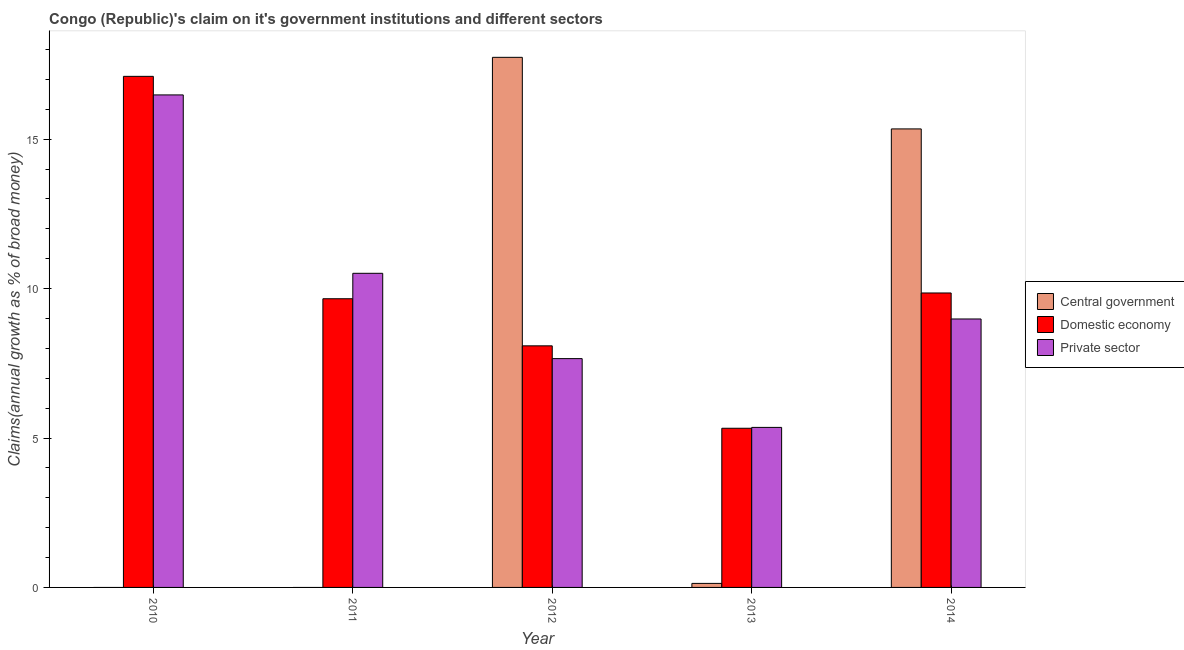Are the number of bars per tick equal to the number of legend labels?
Ensure brevity in your answer.  No. How many bars are there on the 4th tick from the left?
Make the answer very short. 3. How many bars are there on the 4th tick from the right?
Ensure brevity in your answer.  2. What is the percentage of claim on the domestic economy in 2011?
Provide a succinct answer. 9.66. Across all years, what is the maximum percentage of claim on the domestic economy?
Keep it short and to the point. 17.1. Across all years, what is the minimum percentage of claim on the central government?
Provide a succinct answer. 0. In which year was the percentage of claim on the central government maximum?
Your answer should be compact. 2012. What is the total percentage of claim on the private sector in the graph?
Your response must be concise. 48.99. What is the difference between the percentage of claim on the domestic economy in 2010 and that in 2014?
Your response must be concise. 7.25. What is the difference between the percentage of claim on the central government in 2011 and the percentage of claim on the domestic economy in 2012?
Provide a succinct answer. -17.74. What is the average percentage of claim on the domestic economy per year?
Your answer should be compact. 10. In the year 2013, what is the difference between the percentage of claim on the central government and percentage of claim on the private sector?
Offer a very short reply. 0. What is the ratio of the percentage of claim on the domestic economy in 2012 to that in 2014?
Your response must be concise. 0.82. Is the difference between the percentage of claim on the domestic economy in 2010 and 2014 greater than the difference between the percentage of claim on the private sector in 2010 and 2014?
Your answer should be very brief. No. What is the difference between the highest and the second highest percentage of claim on the central government?
Provide a succinct answer. 2.4. What is the difference between the highest and the lowest percentage of claim on the central government?
Make the answer very short. 17.74. What is the difference between two consecutive major ticks on the Y-axis?
Provide a succinct answer. 5. Are the values on the major ticks of Y-axis written in scientific E-notation?
Provide a succinct answer. No. Does the graph contain grids?
Your answer should be compact. No. Where does the legend appear in the graph?
Your answer should be very brief. Center right. How many legend labels are there?
Your response must be concise. 3. What is the title of the graph?
Your response must be concise. Congo (Republic)'s claim on it's government institutions and different sectors. Does "Secondary" appear as one of the legend labels in the graph?
Offer a terse response. No. What is the label or title of the Y-axis?
Give a very brief answer. Claims(annual growth as % of broad money). What is the Claims(annual growth as % of broad money) of Domestic economy in 2010?
Your response must be concise. 17.1. What is the Claims(annual growth as % of broad money) of Private sector in 2010?
Your answer should be compact. 16.48. What is the Claims(annual growth as % of broad money) of Domestic economy in 2011?
Your answer should be compact. 9.66. What is the Claims(annual growth as % of broad money) in Private sector in 2011?
Give a very brief answer. 10.51. What is the Claims(annual growth as % of broad money) of Central government in 2012?
Your answer should be compact. 17.74. What is the Claims(annual growth as % of broad money) in Domestic economy in 2012?
Keep it short and to the point. 8.08. What is the Claims(annual growth as % of broad money) in Private sector in 2012?
Your answer should be compact. 7.66. What is the Claims(annual growth as % of broad money) in Central government in 2013?
Your response must be concise. 0.13. What is the Claims(annual growth as % of broad money) in Domestic economy in 2013?
Provide a short and direct response. 5.33. What is the Claims(annual growth as % of broad money) of Private sector in 2013?
Your answer should be very brief. 5.35. What is the Claims(annual growth as % of broad money) of Central government in 2014?
Ensure brevity in your answer.  15.34. What is the Claims(annual growth as % of broad money) in Domestic economy in 2014?
Provide a succinct answer. 9.85. What is the Claims(annual growth as % of broad money) of Private sector in 2014?
Provide a short and direct response. 8.98. Across all years, what is the maximum Claims(annual growth as % of broad money) of Central government?
Your answer should be very brief. 17.74. Across all years, what is the maximum Claims(annual growth as % of broad money) in Domestic economy?
Offer a very short reply. 17.1. Across all years, what is the maximum Claims(annual growth as % of broad money) in Private sector?
Your answer should be compact. 16.48. Across all years, what is the minimum Claims(annual growth as % of broad money) of Central government?
Offer a very short reply. 0. Across all years, what is the minimum Claims(annual growth as % of broad money) of Domestic economy?
Provide a short and direct response. 5.33. Across all years, what is the minimum Claims(annual growth as % of broad money) in Private sector?
Offer a terse response. 5.35. What is the total Claims(annual growth as % of broad money) of Central government in the graph?
Offer a terse response. 33.22. What is the total Claims(annual growth as % of broad money) of Domestic economy in the graph?
Your response must be concise. 50.02. What is the total Claims(annual growth as % of broad money) in Private sector in the graph?
Give a very brief answer. 48.99. What is the difference between the Claims(annual growth as % of broad money) in Domestic economy in 2010 and that in 2011?
Make the answer very short. 7.44. What is the difference between the Claims(annual growth as % of broad money) of Private sector in 2010 and that in 2011?
Provide a succinct answer. 5.97. What is the difference between the Claims(annual growth as % of broad money) in Domestic economy in 2010 and that in 2012?
Make the answer very short. 9.02. What is the difference between the Claims(annual growth as % of broad money) in Private sector in 2010 and that in 2012?
Ensure brevity in your answer.  8.82. What is the difference between the Claims(annual growth as % of broad money) in Domestic economy in 2010 and that in 2013?
Ensure brevity in your answer.  11.78. What is the difference between the Claims(annual growth as % of broad money) in Private sector in 2010 and that in 2013?
Make the answer very short. 11.13. What is the difference between the Claims(annual growth as % of broad money) of Domestic economy in 2010 and that in 2014?
Make the answer very short. 7.25. What is the difference between the Claims(annual growth as % of broad money) in Private sector in 2010 and that in 2014?
Your answer should be compact. 7.5. What is the difference between the Claims(annual growth as % of broad money) of Domestic economy in 2011 and that in 2012?
Give a very brief answer. 1.58. What is the difference between the Claims(annual growth as % of broad money) of Private sector in 2011 and that in 2012?
Give a very brief answer. 2.85. What is the difference between the Claims(annual growth as % of broad money) in Domestic economy in 2011 and that in 2013?
Provide a short and direct response. 4.33. What is the difference between the Claims(annual growth as % of broad money) of Private sector in 2011 and that in 2013?
Give a very brief answer. 5.16. What is the difference between the Claims(annual growth as % of broad money) of Domestic economy in 2011 and that in 2014?
Offer a terse response. -0.19. What is the difference between the Claims(annual growth as % of broad money) of Private sector in 2011 and that in 2014?
Offer a terse response. 1.53. What is the difference between the Claims(annual growth as % of broad money) of Central government in 2012 and that in 2013?
Provide a short and direct response. 17.6. What is the difference between the Claims(annual growth as % of broad money) in Domestic economy in 2012 and that in 2013?
Give a very brief answer. 2.76. What is the difference between the Claims(annual growth as % of broad money) in Private sector in 2012 and that in 2013?
Offer a very short reply. 2.3. What is the difference between the Claims(annual growth as % of broad money) in Central government in 2012 and that in 2014?
Your answer should be very brief. 2.4. What is the difference between the Claims(annual growth as % of broad money) of Domestic economy in 2012 and that in 2014?
Your answer should be compact. -1.77. What is the difference between the Claims(annual growth as % of broad money) of Private sector in 2012 and that in 2014?
Provide a succinct answer. -1.33. What is the difference between the Claims(annual growth as % of broad money) of Central government in 2013 and that in 2014?
Your answer should be very brief. -15.21. What is the difference between the Claims(annual growth as % of broad money) of Domestic economy in 2013 and that in 2014?
Offer a terse response. -4.53. What is the difference between the Claims(annual growth as % of broad money) in Private sector in 2013 and that in 2014?
Give a very brief answer. -3.63. What is the difference between the Claims(annual growth as % of broad money) in Domestic economy in 2010 and the Claims(annual growth as % of broad money) in Private sector in 2011?
Your answer should be compact. 6.59. What is the difference between the Claims(annual growth as % of broad money) of Domestic economy in 2010 and the Claims(annual growth as % of broad money) of Private sector in 2012?
Give a very brief answer. 9.44. What is the difference between the Claims(annual growth as % of broad money) of Domestic economy in 2010 and the Claims(annual growth as % of broad money) of Private sector in 2013?
Make the answer very short. 11.75. What is the difference between the Claims(annual growth as % of broad money) in Domestic economy in 2010 and the Claims(annual growth as % of broad money) in Private sector in 2014?
Your answer should be compact. 8.12. What is the difference between the Claims(annual growth as % of broad money) of Domestic economy in 2011 and the Claims(annual growth as % of broad money) of Private sector in 2012?
Offer a very short reply. 2. What is the difference between the Claims(annual growth as % of broad money) of Domestic economy in 2011 and the Claims(annual growth as % of broad money) of Private sector in 2013?
Your answer should be compact. 4.31. What is the difference between the Claims(annual growth as % of broad money) of Domestic economy in 2011 and the Claims(annual growth as % of broad money) of Private sector in 2014?
Ensure brevity in your answer.  0.68. What is the difference between the Claims(annual growth as % of broad money) of Central government in 2012 and the Claims(annual growth as % of broad money) of Domestic economy in 2013?
Your response must be concise. 12.41. What is the difference between the Claims(annual growth as % of broad money) of Central government in 2012 and the Claims(annual growth as % of broad money) of Private sector in 2013?
Keep it short and to the point. 12.38. What is the difference between the Claims(annual growth as % of broad money) in Domestic economy in 2012 and the Claims(annual growth as % of broad money) in Private sector in 2013?
Make the answer very short. 2.73. What is the difference between the Claims(annual growth as % of broad money) of Central government in 2012 and the Claims(annual growth as % of broad money) of Domestic economy in 2014?
Offer a very short reply. 7.88. What is the difference between the Claims(annual growth as % of broad money) in Central government in 2012 and the Claims(annual growth as % of broad money) in Private sector in 2014?
Your answer should be compact. 8.76. What is the difference between the Claims(annual growth as % of broad money) in Domestic economy in 2012 and the Claims(annual growth as % of broad money) in Private sector in 2014?
Ensure brevity in your answer.  -0.9. What is the difference between the Claims(annual growth as % of broad money) of Central government in 2013 and the Claims(annual growth as % of broad money) of Domestic economy in 2014?
Provide a succinct answer. -9.72. What is the difference between the Claims(annual growth as % of broad money) of Central government in 2013 and the Claims(annual growth as % of broad money) of Private sector in 2014?
Offer a terse response. -8.85. What is the difference between the Claims(annual growth as % of broad money) in Domestic economy in 2013 and the Claims(annual growth as % of broad money) in Private sector in 2014?
Your response must be concise. -3.66. What is the average Claims(annual growth as % of broad money) in Central government per year?
Make the answer very short. 6.64. What is the average Claims(annual growth as % of broad money) of Domestic economy per year?
Offer a very short reply. 10.01. What is the average Claims(annual growth as % of broad money) of Private sector per year?
Your answer should be compact. 9.8. In the year 2010, what is the difference between the Claims(annual growth as % of broad money) of Domestic economy and Claims(annual growth as % of broad money) of Private sector?
Make the answer very short. 0.62. In the year 2011, what is the difference between the Claims(annual growth as % of broad money) of Domestic economy and Claims(annual growth as % of broad money) of Private sector?
Ensure brevity in your answer.  -0.85. In the year 2012, what is the difference between the Claims(annual growth as % of broad money) of Central government and Claims(annual growth as % of broad money) of Domestic economy?
Your answer should be very brief. 9.65. In the year 2012, what is the difference between the Claims(annual growth as % of broad money) in Central government and Claims(annual growth as % of broad money) in Private sector?
Provide a succinct answer. 10.08. In the year 2012, what is the difference between the Claims(annual growth as % of broad money) in Domestic economy and Claims(annual growth as % of broad money) in Private sector?
Offer a very short reply. 0.43. In the year 2013, what is the difference between the Claims(annual growth as % of broad money) in Central government and Claims(annual growth as % of broad money) in Domestic economy?
Your answer should be compact. -5.19. In the year 2013, what is the difference between the Claims(annual growth as % of broad money) in Central government and Claims(annual growth as % of broad money) in Private sector?
Give a very brief answer. -5.22. In the year 2013, what is the difference between the Claims(annual growth as % of broad money) in Domestic economy and Claims(annual growth as % of broad money) in Private sector?
Give a very brief answer. -0.03. In the year 2014, what is the difference between the Claims(annual growth as % of broad money) in Central government and Claims(annual growth as % of broad money) in Domestic economy?
Your response must be concise. 5.49. In the year 2014, what is the difference between the Claims(annual growth as % of broad money) of Central government and Claims(annual growth as % of broad money) of Private sector?
Ensure brevity in your answer.  6.36. In the year 2014, what is the difference between the Claims(annual growth as % of broad money) of Domestic economy and Claims(annual growth as % of broad money) of Private sector?
Offer a terse response. 0.87. What is the ratio of the Claims(annual growth as % of broad money) in Domestic economy in 2010 to that in 2011?
Your answer should be compact. 1.77. What is the ratio of the Claims(annual growth as % of broad money) of Private sector in 2010 to that in 2011?
Provide a succinct answer. 1.57. What is the ratio of the Claims(annual growth as % of broad money) in Domestic economy in 2010 to that in 2012?
Your answer should be compact. 2.12. What is the ratio of the Claims(annual growth as % of broad money) in Private sector in 2010 to that in 2012?
Keep it short and to the point. 2.15. What is the ratio of the Claims(annual growth as % of broad money) in Domestic economy in 2010 to that in 2013?
Offer a very short reply. 3.21. What is the ratio of the Claims(annual growth as % of broad money) in Private sector in 2010 to that in 2013?
Provide a short and direct response. 3.08. What is the ratio of the Claims(annual growth as % of broad money) in Domestic economy in 2010 to that in 2014?
Make the answer very short. 1.74. What is the ratio of the Claims(annual growth as % of broad money) of Private sector in 2010 to that in 2014?
Make the answer very short. 1.83. What is the ratio of the Claims(annual growth as % of broad money) of Domestic economy in 2011 to that in 2012?
Your response must be concise. 1.2. What is the ratio of the Claims(annual growth as % of broad money) in Private sector in 2011 to that in 2012?
Your answer should be very brief. 1.37. What is the ratio of the Claims(annual growth as % of broad money) of Domestic economy in 2011 to that in 2013?
Ensure brevity in your answer.  1.81. What is the ratio of the Claims(annual growth as % of broad money) of Private sector in 2011 to that in 2013?
Provide a short and direct response. 1.96. What is the ratio of the Claims(annual growth as % of broad money) of Domestic economy in 2011 to that in 2014?
Your answer should be very brief. 0.98. What is the ratio of the Claims(annual growth as % of broad money) in Private sector in 2011 to that in 2014?
Ensure brevity in your answer.  1.17. What is the ratio of the Claims(annual growth as % of broad money) in Central government in 2012 to that in 2013?
Ensure brevity in your answer.  131.59. What is the ratio of the Claims(annual growth as % of broad money) in Domestic economy in 2012 to that in 2013?
Your answer should be very brief. 1.52. What is the ratio of the Claims(annual growth as % of broad money) in Private sector in 2012 to that in 2013?
Your answer should be very brief. 1.43. What is the ratio of the Claims(annual growth as % of broad money) in Central government in 2012 to that in 2014?
Provide a short and direct response. 1.16. What is the ratio of the Claims(annual growth as % of broad money) in Domestic economy in 2012 to that in 2014?
Keep it short and to the point. 0.82. What is the ratio of the Claims(annual growth as % of broad money) of Private sector in 2012 to that in 2014?
Give a very brief answer. 0.85. What is the ratio of the Claims(annual growth as % of broad money) in Central government in 2013 to that in 2014?
Your answer should be very brief. 0.01. What is the ratio of the Claims(annual growth as % of broad money) of Domestic economy in 2013 to that in 2014?
Your answer should be very brief. 0.54. What is the ratio of the Claims(annual growth as % of broad money) of Private sector in 2013 to that in 2014?
Provide a short and direct response. 0.6. What is the difference between the highest and the second highest Claims(annual growth as % of broad money) of Central government?
Provide a short and direct response. 2.4. What is the difference between the highest and the second highest Claims(annual growth as % of broad money) in Domestic economy?
Your response must be concise. 7.25. What is the difference between the highest and the second highest Claims(annual growth as % of broad money) of Private sector?
Keep it short and to the point. 5.97. What is the difference between the highest and the lowest Claims(annual growth as % of broad money) of Central government?
Give a very brief answer. 17.74. What is the difference between the highest and the lowest Claims(annual growth as % of broad money) of Domestic economy?
Keep it short and to the point. 11.78. What is the difference between the highest and the lowest Claims(annual growth as % of broad money) of Private sector?
Offer a terse response. 11.13. 